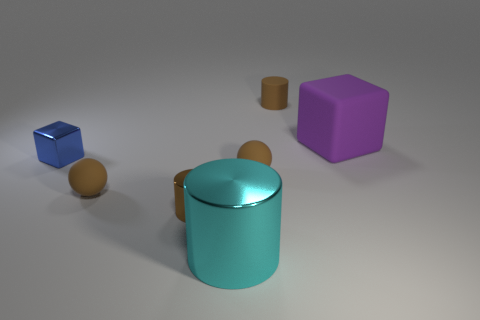Add 2 big green balls. How many objects exist? 9 Subtract all balls. How many objects are left? 5 Subtract all red matte cylinders. Subtract all small matte cylinders. How many objects are left? 6 Add 6 shiny things. How many shiny things are left? 9 Add 2 matte balls. How many matte balls exist? 4 Subtract 1 cyan cylinders. How many objects are left? 6 